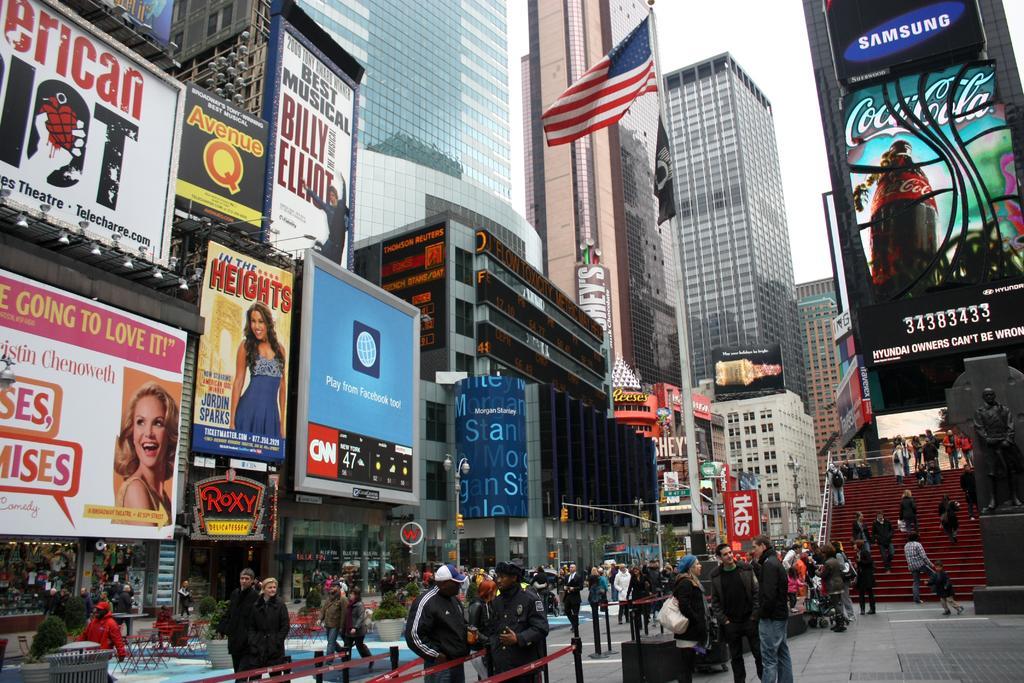Please provide a concise description of this image. In the picture I can see people walking on the road, I can see flower pots, light poles, I can see tables, statue and steps on the right side of the image, I can see boards, banners, flags to the pole, tower buildings and the sky in the background. 